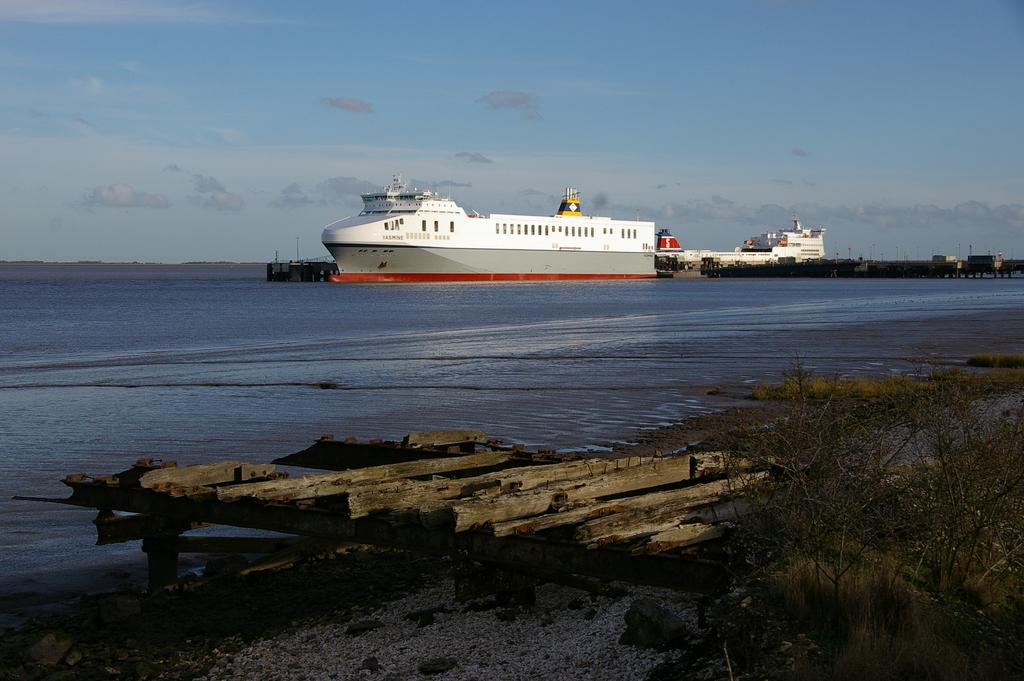What is located in the middle of the image? There are boats in the middle of the image. What can be seen at the bottom of the image? There are plants and wooden sticks at the bottom of the image, and there is also water. What is visible at the top of the image? The sky is visible at the top of the image, and there are clouds present in the sky. Who is the owner of the coach in the image? There is no coach present in the image. What class is being taught in the image? There is no class or teaching activity depicted in the image. 